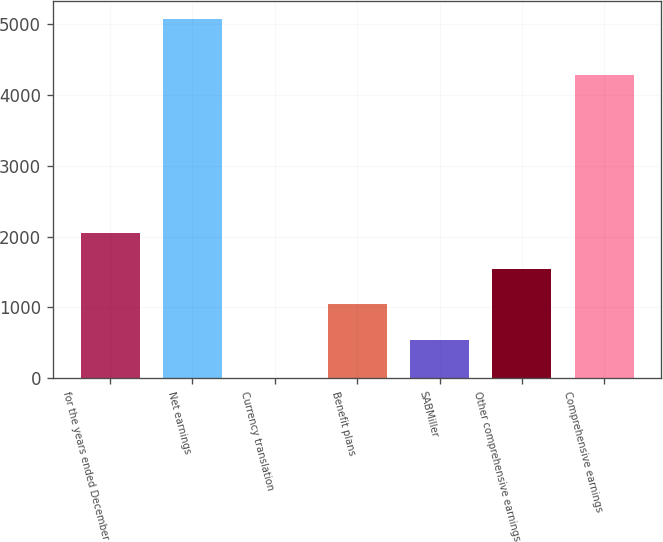<chart> <loc_0><loc_0><loc_500><loc_500><bar_chart><fcel>for the years ended December<fcel>Net earnings<fcel>Currency translation<fcel>Benefit plans<fcel>SABMiller<fcel>Other comprehensive earnings<fcel>Comprehensive earnings<nl><fcel>2055.4<fcel>5070<fcel>2<fcel>1041.8<fcel>535<fcel>1548.6<fcel>4272.8<nl></chart> 